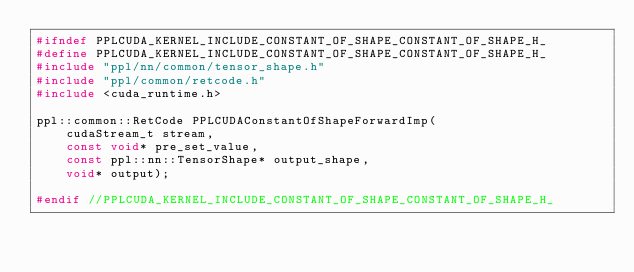<code> <loc_0><loc_0><loc_500><loc_500><_C_>#ifndef PPLCUDA_KERNEL_INCLUDE_CONSTANT_OF_SHAPE_CONSTANT_OF_SHAPE_H_
#define PPLCUDA_KERNEL_INCLUDE_CONSTANT_OF_SHAPE_CONSTANT_OF_SHAPE_H_
#include "ppl/nn/common/tensor_shape.h"
#include "ppl/common/retcode.h"
#include <cuda_runtime.h>

ppl::common::RetCode PPLCUDAConstantOfShapeForwardImp(
    cudaStream_t stream,
    const void* pre_set_value,
    const ppl::nn::TensorShape* output_shape,
    void* output);

#endif //PPLCUDA_KERNEL_INCLUDE_CONSTANT_OF_SHAPE_CONSTANT_OF_SHAPE_H_
</code> 